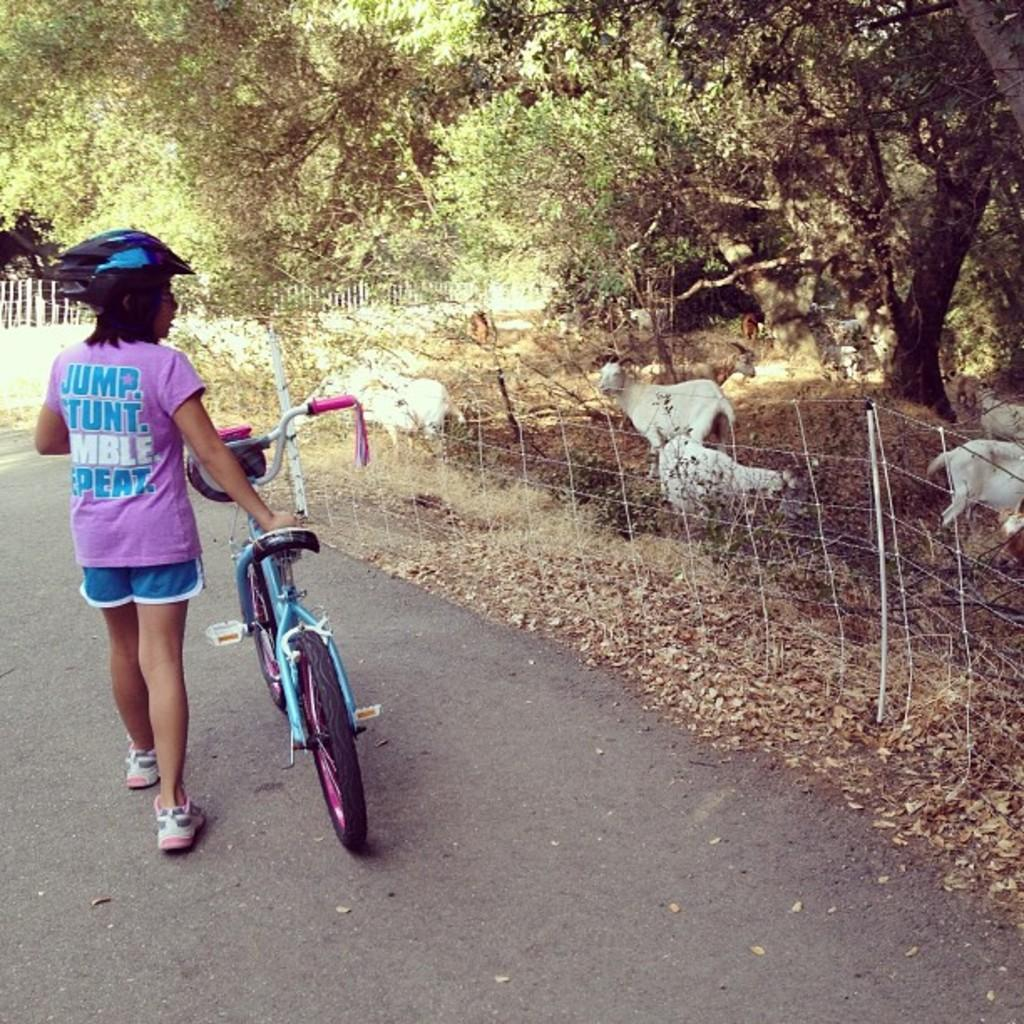Who is present in the image? There is a girl in the image. What is the girl wearing? The girl is wearing a helmet. What is the girl holding in the image? The girl is holding a cycle. What can be seen on the right side of the image? There are trees, animals, and fencing on the right side of the image. What type of chance game is being played in the image? There is no chance game present in the image. What is the girl using to carry the animals in the image? The girl is not carrying any animals in the image, and there is no yoke present. 